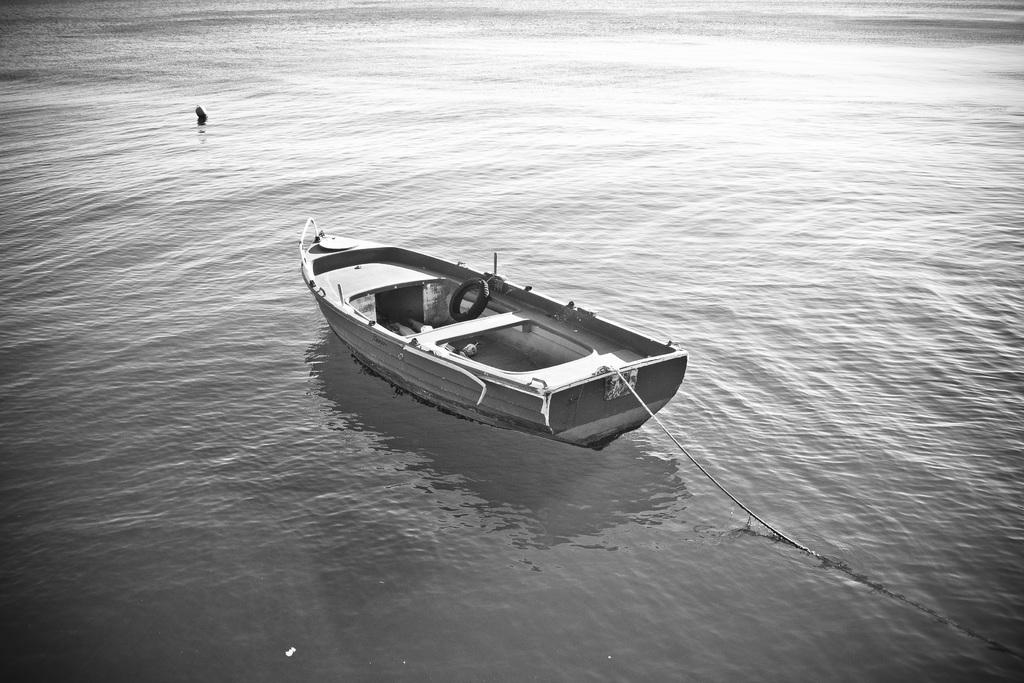What is the main subject of the image? The main subject of the image is a boat. Where is the boat located? The boat is on the water. Are there any people in the image? Yes, there is a person in the water. What is the color scheme of the image? The image is in black and white. What type of meat is being weighed in the image? There is no meat or any indication of weighing in the image. 